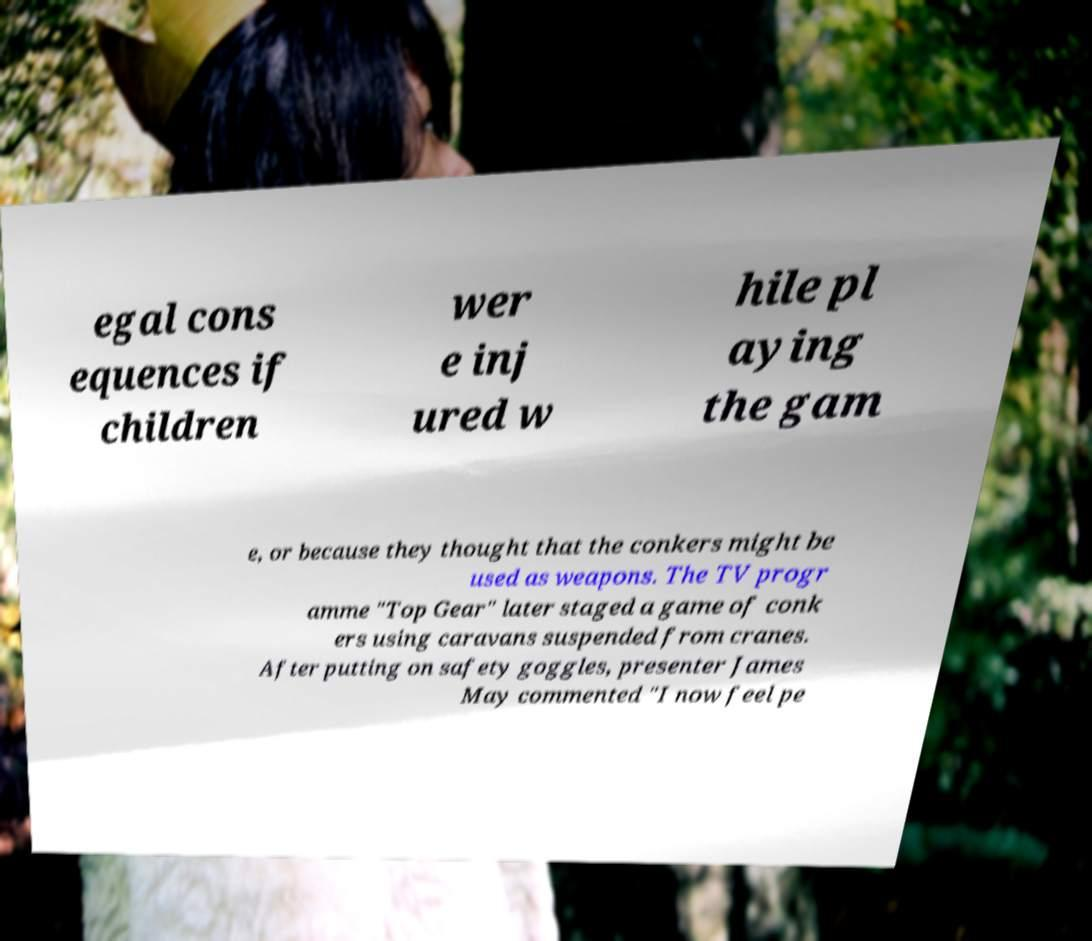What messages or text are displayed in this image? I need them in a readable, typed format. egal cons equences if children wer e inj ured w hile pl aying the gam e, or because they thought that the conkers might be used as weapons. The TV progr amme "Top Gear" later staged a game of conk ers using caravans suspended from cranes. After putting on safety goggles, presenter James May commented "I now feel pe 